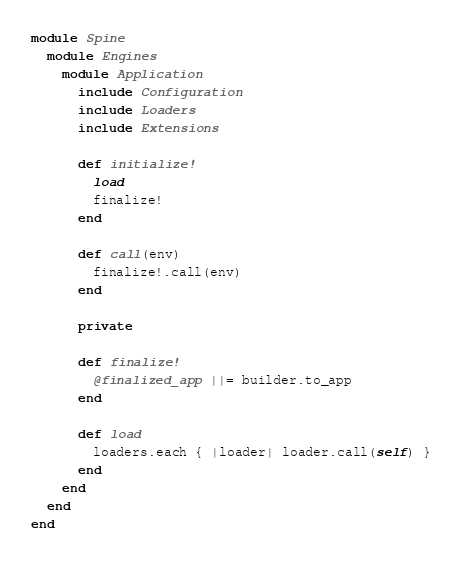<code> <loc_0><loc_0><loc_500><loc_500><_Ruby_>module Spine
  module Engines
    module Application
      include Configuration
      include Loaders
      include Extensions

      def initialize!
        load
        finalize!
      end

      def call(env)
        finalize!.call(env)
      end

      private

      def finalize!
        @finalized_app ||= builder.to_app
      end

      def load
        loaders.each { |loader| loader.call(self) }
      end
    end
  end
end
</code> 